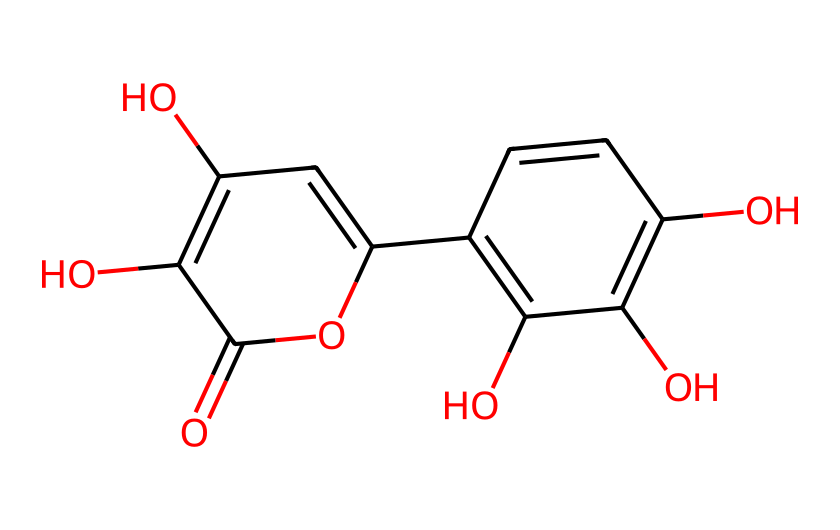How many hydroxyl groups are present in this chemical? By examining the structure, we can identify each instance of the hydroxyl group (-OH) within the chemical. There are four -OH groups indicated in the structure.
Answer: four What is the molecular weight of quercetin? To find the molecular weight, one must consider the atom types and their counts indicated in the structure. The molecular formula for quercetin is C15H10O7, and calculating the weights of these atoms gives a total of approximately 302.24 g/mol.
Answer: 302.24 g/mol Identify the primary functional group in this chemical. The structure showcases multiple functional groups, but the dominant one that stands out is the phenolic hydroxyl group, characterized by the -OH attached to a benzene ring. This is typical for flavonoids.
Answer: phenolic hydroxyl How many rings are present in the structure? The molecule has two interconnected aromatic rings, which can be recognized by examining the cyclic structure characteristic of flavonoids. Each ring contains alternating double bonds, typical of aromatic compounds.
Answer: two What type of compound is quercetin classified as? Quercetin falls under the category of flavonoids, which are polyphenolic compounds known for their antioxidant properties. This classification can be inferred from its structural characteristics, including the arrangement of the rings and functional groups.
Answer: flavonoid Which part of the chemical contributes to its antioxidant properties? The presence of multiple hydroxyl groups within the structure is responsible for the antioxidant activity, as they can donate hydrogen atoms to free radicals, thus neutralizing them. This is a fundamental property of phenolic compounds.
Answer: hydroxyl groups What is the significance of the ketone group in this structure? The ketone group (C=O) plays a role in the overall reactivity and stability of the molecule. In the context of quercetin, it may also influence its flavonoid properties and biological activities, including modulation of various enzymatic processes.
Answer: reactivity and stability 